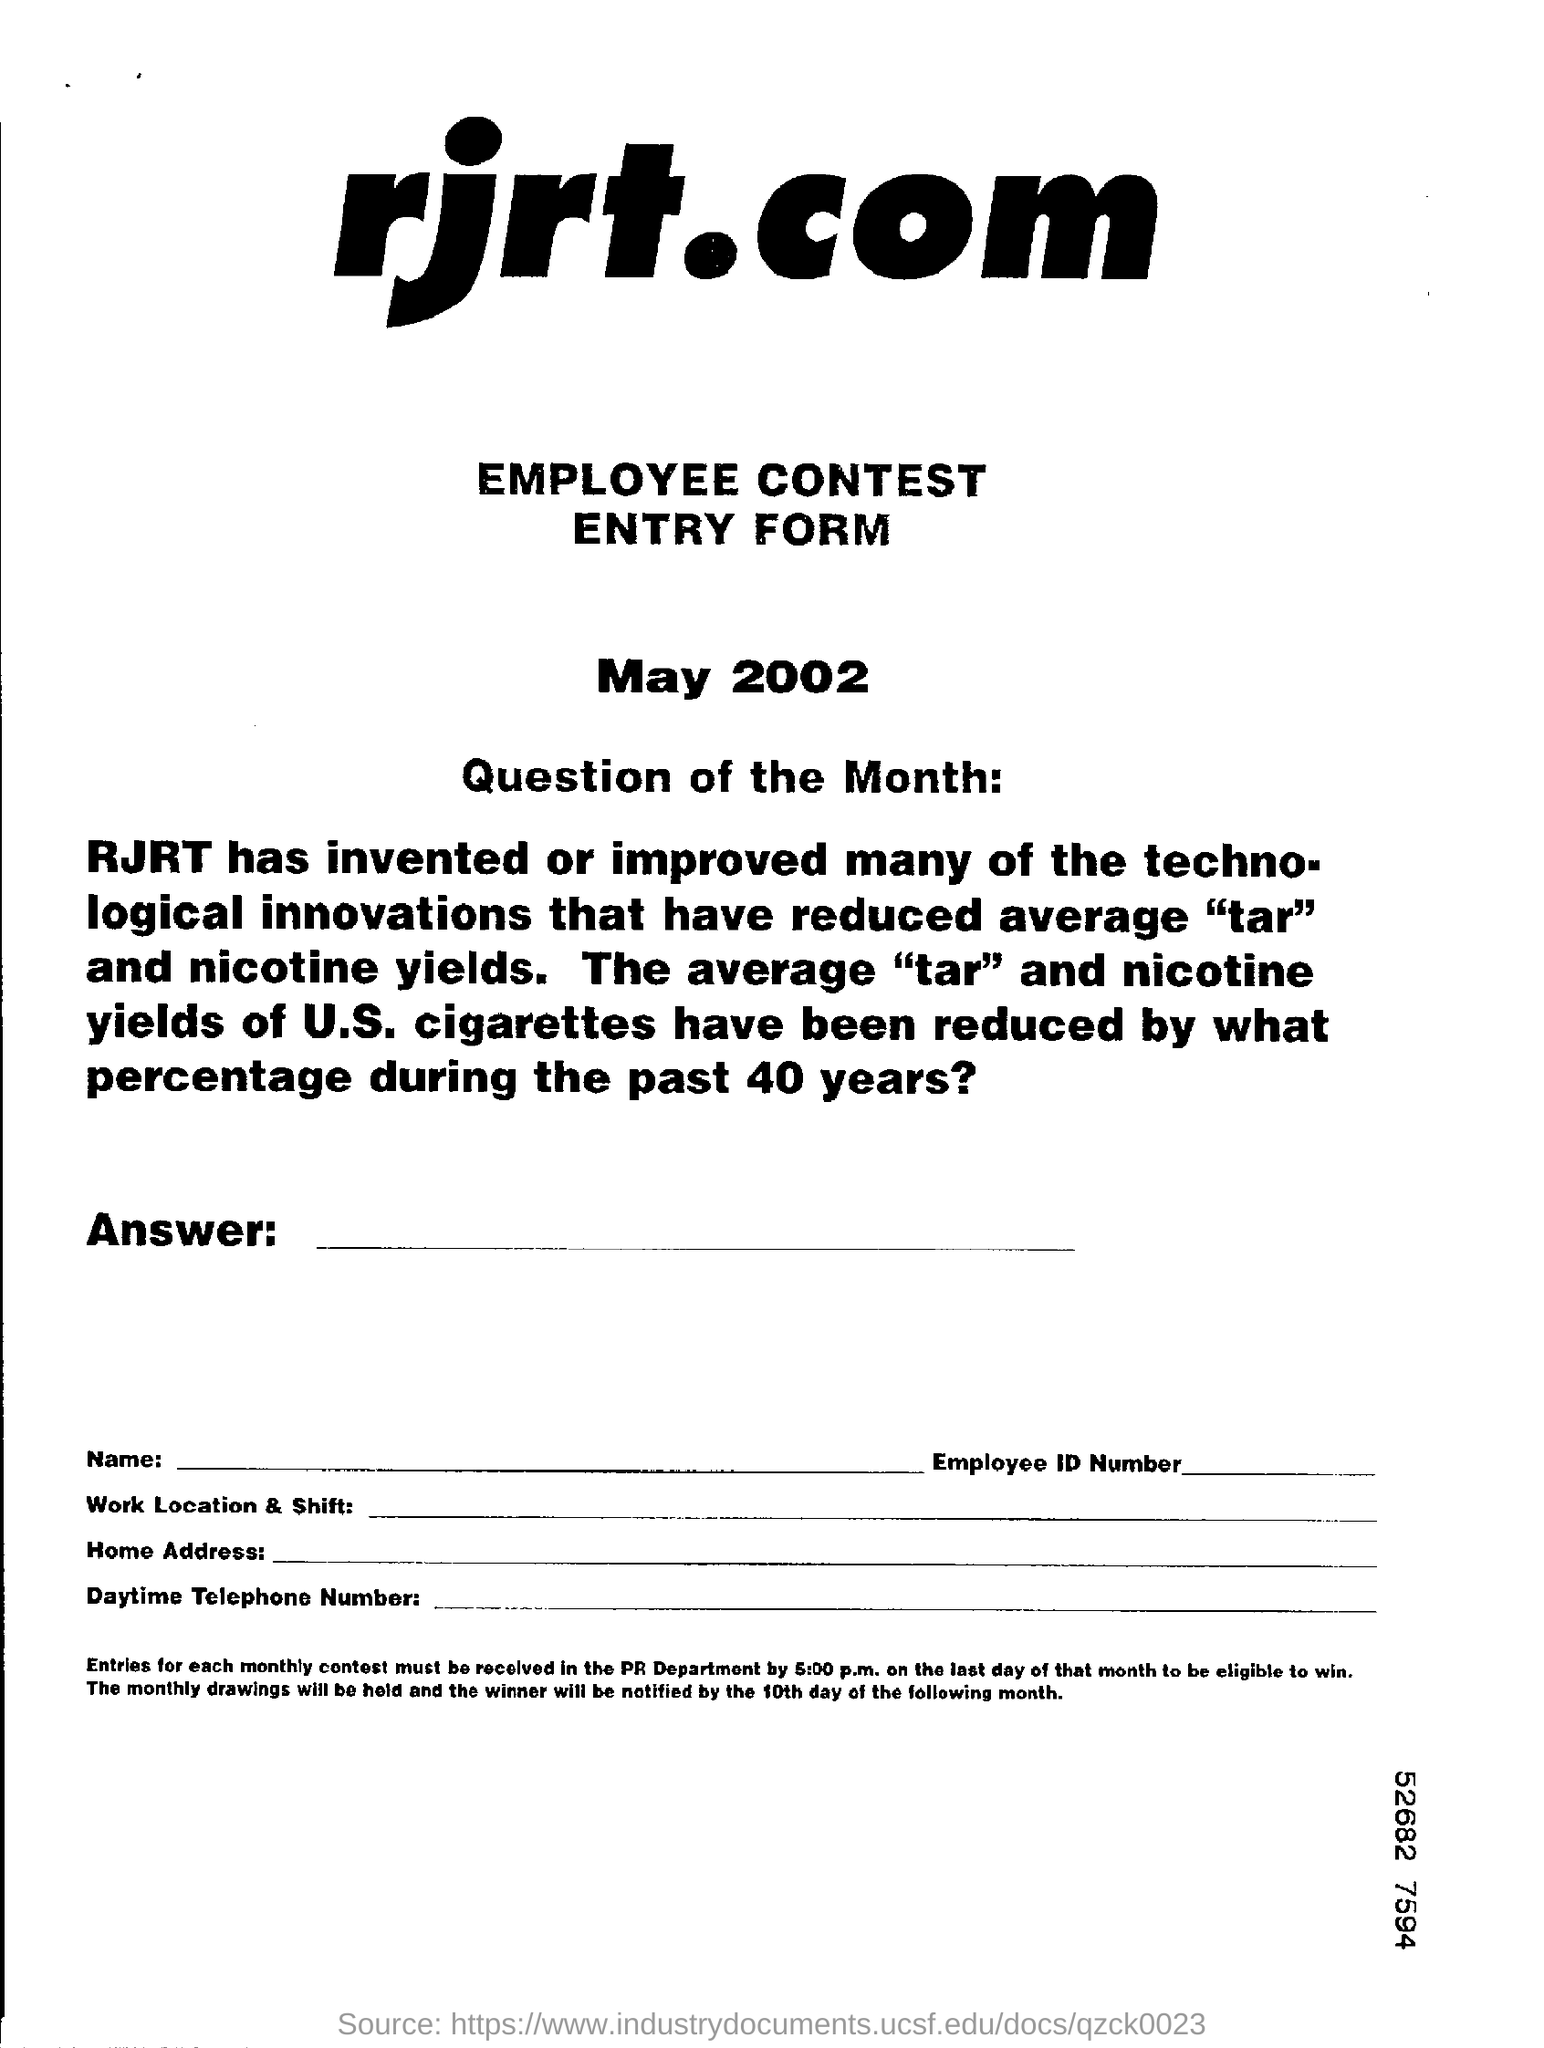What type of form is given here?
Offer a terse response. EMPLOYEE CONTEST ENTRY FORM. What is the date mentioned in this form?
Your response must be concise. May 2002. 